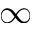Convert formula to latex. <formula><loc_0><loc_0><loc_500><loc_500>\infty</formula> 